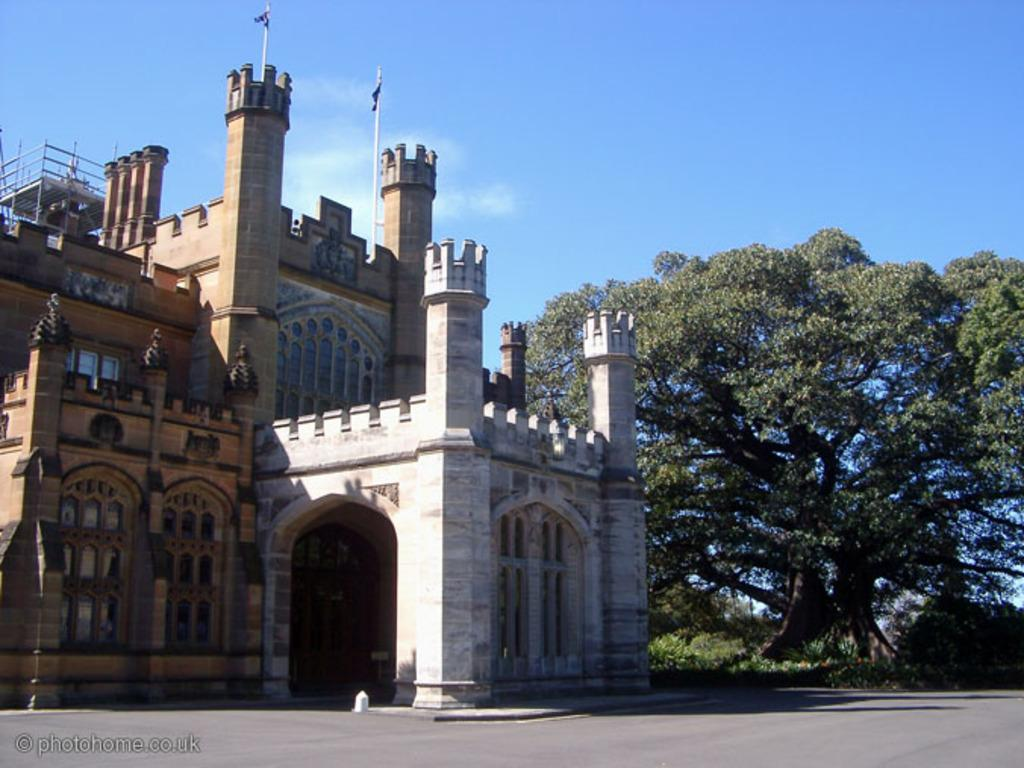What structure is featured in the image with flags? There is a building with flags in the image. What is located in front of the building? There is a ground in front of the building. What type of natural elements can be seen in the image? Trees are visible in the image. What is visible above the building and trees? The sky is visible in the image. Can you tell me how many points the building has in the image? The building does not have any points; it is a solid structure. What emotion is the building feeling in the image? Buildings do not have emotions, so it cannot be determined if the building is feeling regret or any other emotion. 